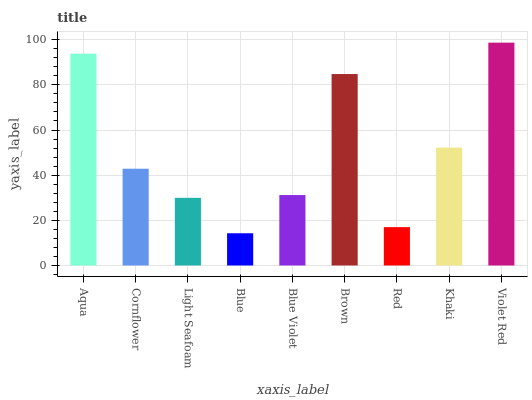Is Blue the minimum?
Answer yes or no. Yes. Is Violet Red the maximum?
Answer yes or no. Yes. Is Cornflower the minimum?
Answer yes or no. No. Is Cornflower the maximum?
Answer yes or no. No. Is Aqua greater than Cornflower?
Answer yes or no. Yes. Is Cornflower less than Aqua?
Answer yes or no. Yes. Is Cornflower greater than Aqua?
Answer yes or no. No. Is Aqua less than Cornflower?
Answer yes or no. No. Is Cornflower the high median?
Answer yes or no. Yes. Is Cornflower the low median?
Answer yes or no. Yes. Is Blue Violet the high median?
Answer yes or no. No. Is Violet Red the low median?
Answer yes or no. No. 